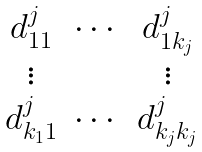Convert formula to latex. <formula><loc_0><loc_0><loc_500><loc_500>\begin{matrix} d ^ { j } _ { 1 1 } & \cdots & d ^ { j } _ { 1 k _ { j } } \\ \vdots & & \vdots \\ d ^ { j } _ { k _ { 1 } 1 } & \cdots & d ^ { j } _ { k _ { j } k _ { j } } \end{matrix}</formula> 